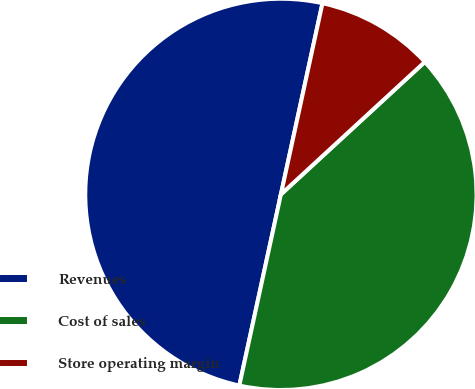Convert chart. <chart><loc_0><loc_0><loc_500><loc_500><pie_chart><fcel>Revenues<fcel>Cost of sales<fcel>Store operating margin<nl><fcel>50.0%<fcel>40.25%<fcel>9.75%<nl></chart> 